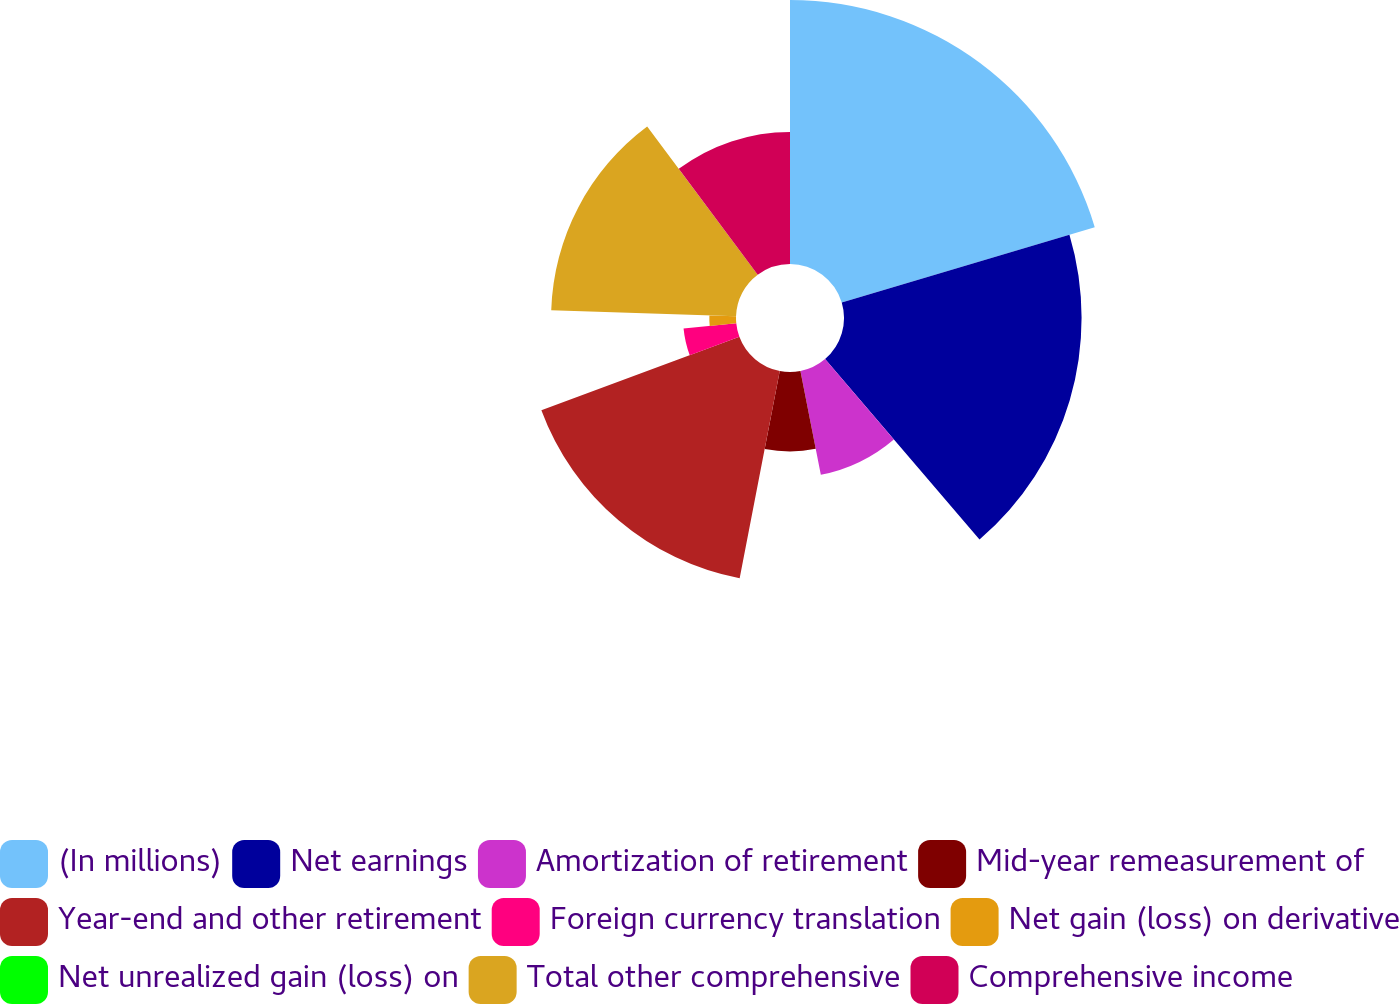Convert chart. <chart><loc_0><loc_0><loc_500><loc_500><pie_chart><fcel>(In millions)<fcel>Net earnings<fcel>Amortization of retirement<fcel>Mid-year remeasurement of<fcel>Year-end and other retirement<fcel>Foreign currency translation<fcel>Net gain (loss) on derivative<fcel>Net unrealized gain (loss) on<fcel>Total other comprehensive<fcel>Comprehensive income<nl><fcel>20.39%<fcel>18.35%<fcel>8.17%<fcel>6.13%<fcel>16.31%<fcel>4.09%<fcel>2.06%<fcel>0.02%<fcel>14.28%<fcel>10.2%<nl></chart> 